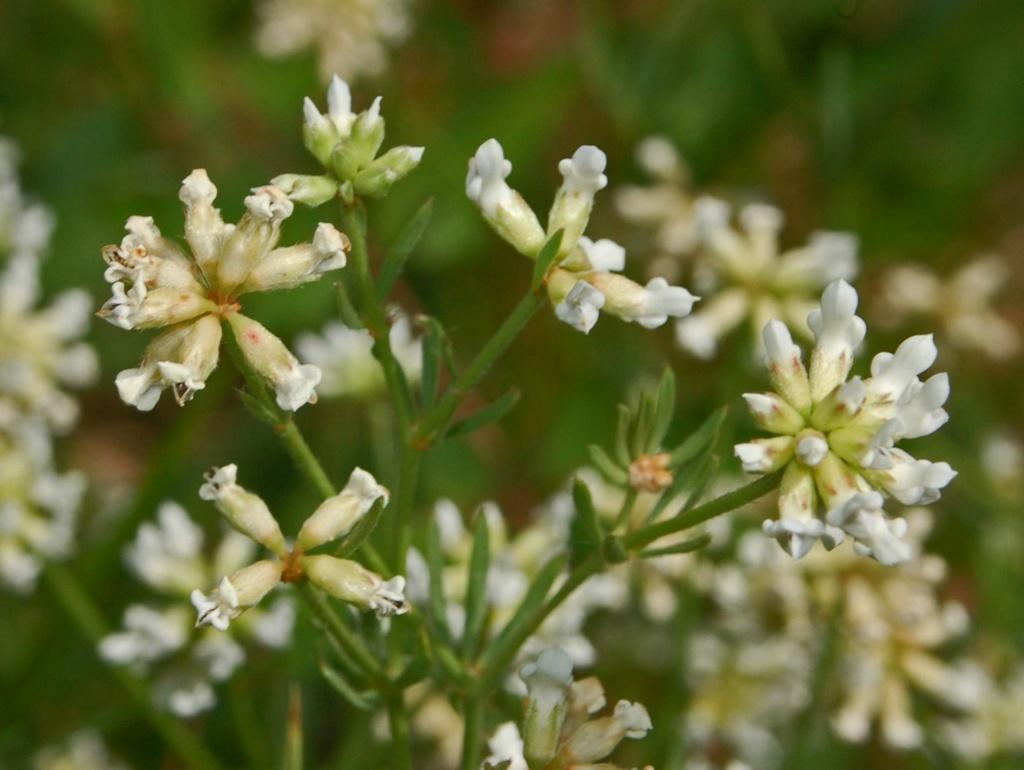What is present in the image? There is a plant in the image. What can be observed about the plant? The plant has a bunch of flowers. What type of grape is being used to enhance the hearing ability of the plant in the image? There is no grape or mention of enhanced hearing ability in the image; it simply features a plant with a bunch of flowers. 